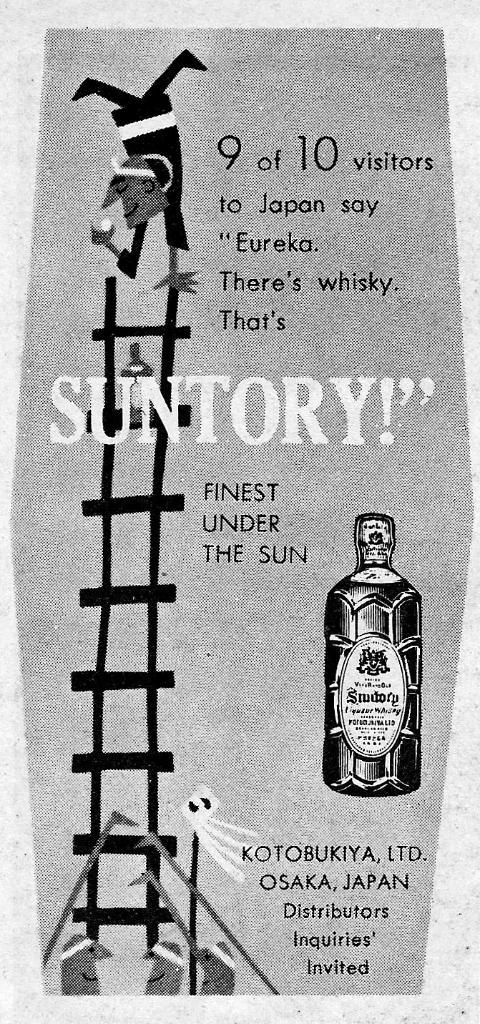What type of advertisement is depicted in the image? The image is an old advertisement for whisky. Can you describe the product being advertised? The product being advertised is whisky. What type of tree is featured in the advertisement? There is no tree present in the advertisement; it is an advertisement for whisky. What musical instrument is being played in the advertisement? There is no musical instrument present in the advertisement; it is an advertisement for whisky. 